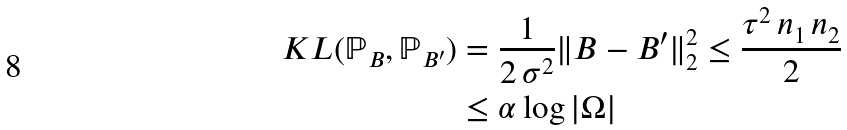Convert formula to latex. <formula><loc_0><loc_0><loc_500><loc_500>K L ( \mathbb { P } _ { B } , \mathbb { P } _ { B ^ { \prime } } ) & = \frac { 1 } { 2 \, \sigma ^ { 2 } } \| B - B ^ { \prime } \| ^ { 2 } _ { 2 } \leq \frac { \tau ^ { 2 } \, n _ { 1 } \, n _ { 2 } } { 2 } \\ & \leq \alpha \log \left | \Omega \right |</formula> 